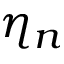Convert formula to latex. <formula><loc_0><loc_0><loc_500><loc_500>\eta _ { n }</formula> 